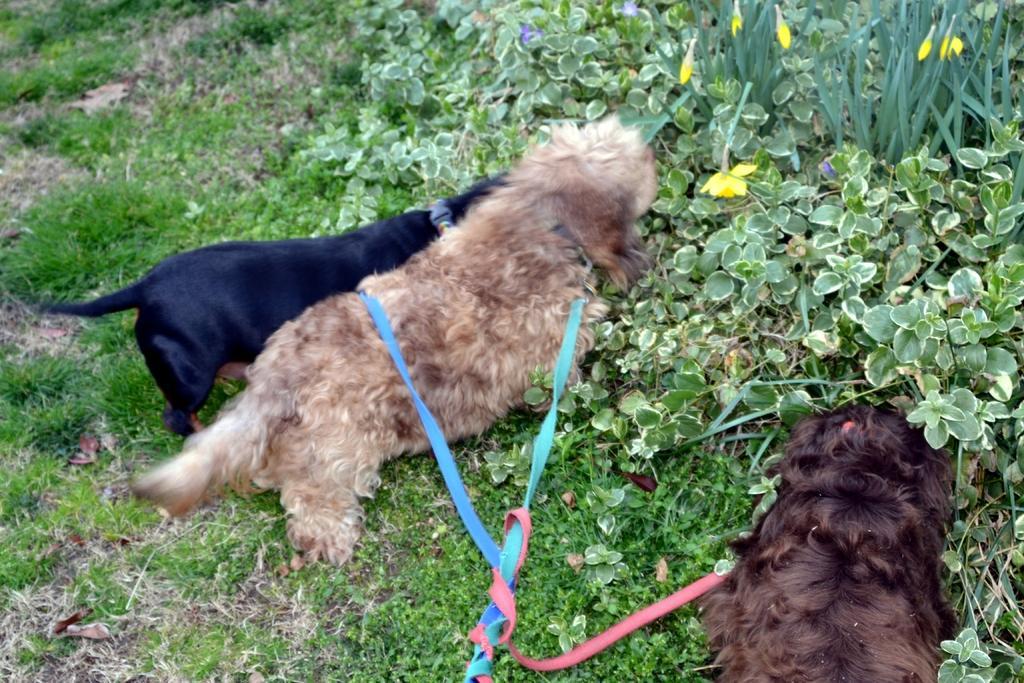Could you give a brief overview of what you see in this image? In this image we can see dogs standing on the grass on the ground and they are tied with belts and we can see plants with flowers on the ground. 